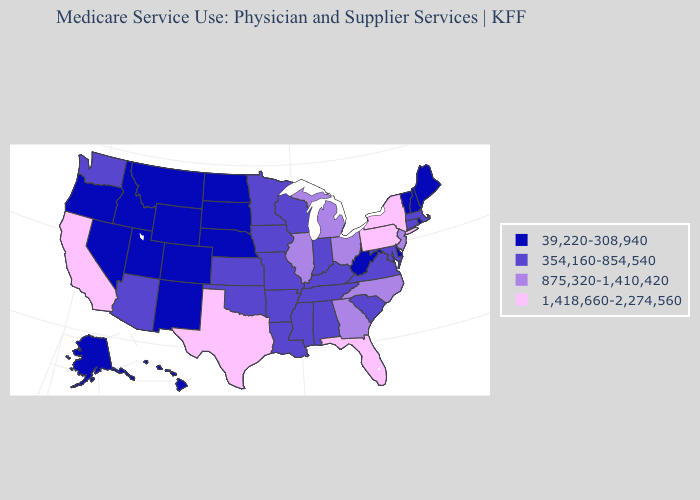What is the value of Maine?
Keep it brief. 39,220-308,940. Which states hav the highest value in the Northeast?
Answer briefly. New York, Pennsylvania. Name the states that have a value in the range 1,418,660-2,274,560?
Answer briefly. California, Florida, New York, Pennsylvania, Texas. Which states have the highest value in the USA?
Answer briefly. California, Florida, New York, Pennsylvania, Texas. Which states hav the highest value in the MidWest?
Answer briefly. Illinois, Michigan, Ohio. Name the states that have a value in the range 39,220-308,940?
Keep it brief. Alaska, Colorado, Delaware, Hawaii, Idaho, Maine, Montana, Nebraska, Nevada, New Hampshire, New Mexico, North Dakota, Oregon, Rhode Island, South Dakota, Utah, Vermont, West Virginia, Wyoming. Name the states that have a value in the range 875,320-1,410,420?
Quick response, please. Georgia, Illinois, Michigan, New Jersey, North Carolina, Ohio. Name the states that have a value in the range 39,220-308,940?
Quick response, please. Alaska, Colorado, Delaware, Hawaii, Idaho, Maine, Montana, Nebraska, Nevada, New Hampshire, New Mexico, North Dakota, Oregon, Rhode Island, South Dakota, Utah, Vermont, West Virginia, Wyoming. What is the value of New Jersey?
Be succinct. 875,320-1,410,420. What is the lowest value in the Northeast?
Write a very short answer. 39,220-308,940. Which states have the lowest value in the USA?
Concise answer only. Alaska, Colorado, Delaware, Hawaii, Idaho, Maine, Montana, Nebraska, Nevada, New Hampshire, New Mexico, North Dakota, Oregon, Rhode Island, South Dakota, Utah, Vermont, West Virginia, Wyoming. Among the states that border Delaware , which have the lowest value?
Quick response, please. Maryland. Does Texas have the same value as Minnesota?
Quick response, please. No. Name the states that have a value in the range 1,418,660-2,274,560?
Short answer required. California, Florida, New York, Pennsylvania, Texas. What is the value of Alaska?
Write a very short answer. 39,220-308,940. 